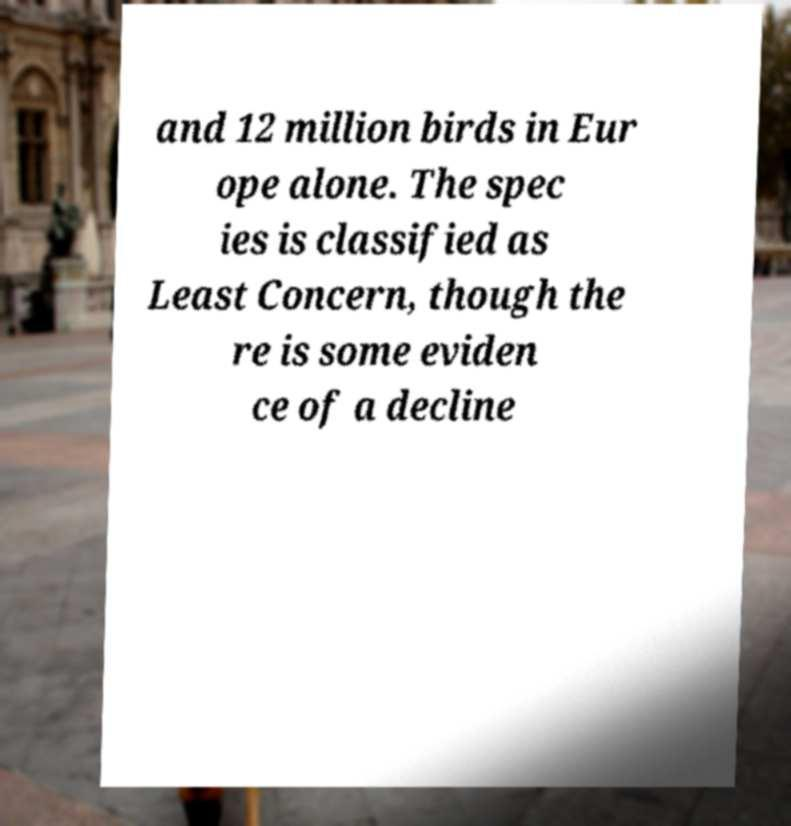There's text embedded in this image that I need extracted. Can you transcribe it verbatim? and 12 million birds in Eur ope alone. The spec ies is classified as Least Concern, though the re is some eviden ce of a decline 